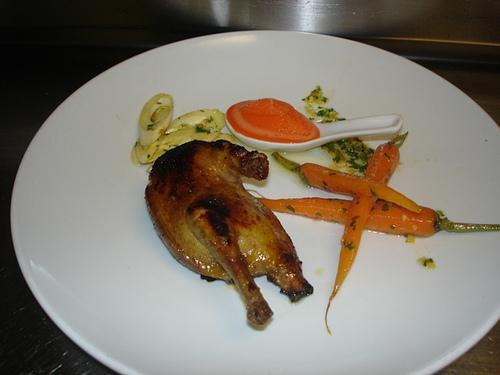How many bowls?
Give a very brief answer. 0. How many sets of three carrots are on the plate?
Give a very brief answer. 1. How many carrots are in the photo?
Give a very brief answer. 3. 